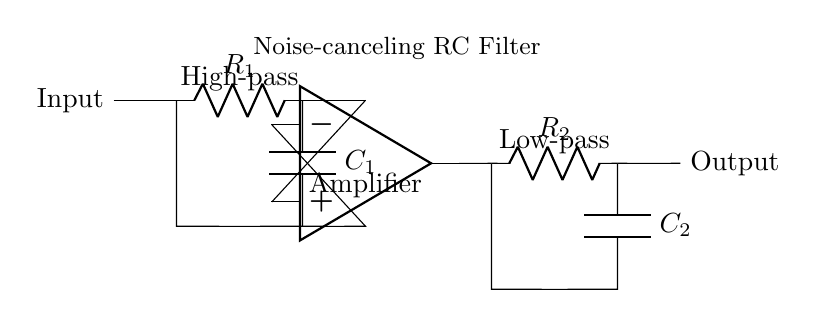What type of filter is used at the input? The circuit features a high-pass filter at the input, as indicated by the arrangement of the resistor and capacitor. This design allows high-frequency signals to pass while attenuating low frequencies.
Answer: High-pass What are the components of the noise-canceling RC filter? The noise-canceling RC filter consists of two main components: a resistor and a capacitor, which are used to block unwanted noise by filtering out these frequencies.
Answer: Resistor, Capacitor What is the purpose of the amplifier in the circuit? The amplifier boosts the signal level, ensuring that the output is strong enough for further processing. It provides necessary gain to the audio signal after filtering, enhancing overall clarity of sound in headphones.
Answer: Signal boost Which components make up the low-pass filter section? The low-pass filter is composed of a resistor and a capacitor connected in series, which allows low-frequency signals to pass through while attenuating higher frequencies.
Answer: Resistor, Capacitor What happens to the high frequencies in this circuit? High frequencies are blocked or attenuated at the high-pass filter while low frequencies are allowed through the low-pass filter, shaping the audio output to improve clarity.
Answer: Attenuated What is the output labeled as in the circuit? The output is clearly labeled as "Output," showing where the processed audio signal exits the circuit for the headphones.
Answer: Output 